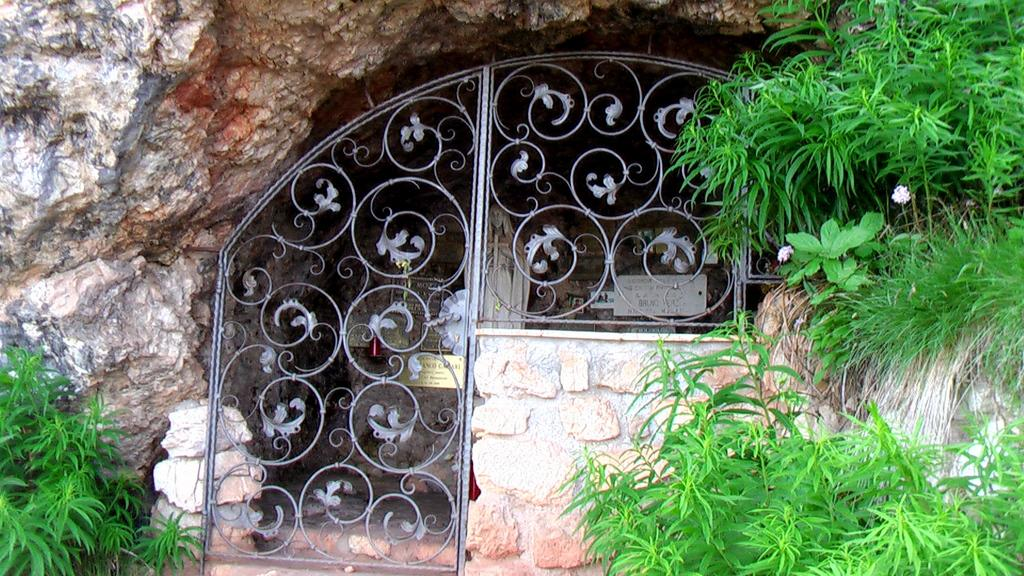What is the main structure in the middle of the image? There is an iron frame in the middle of the image. What else can be seen in the image besides the iron frame? There is a statue in the image. What type of vegetation is present on either side of the image? There are plants on either side of the image. What type of letter is being held by the statue in the image? There is no letter present in the image, and the statue is not holding anything. 